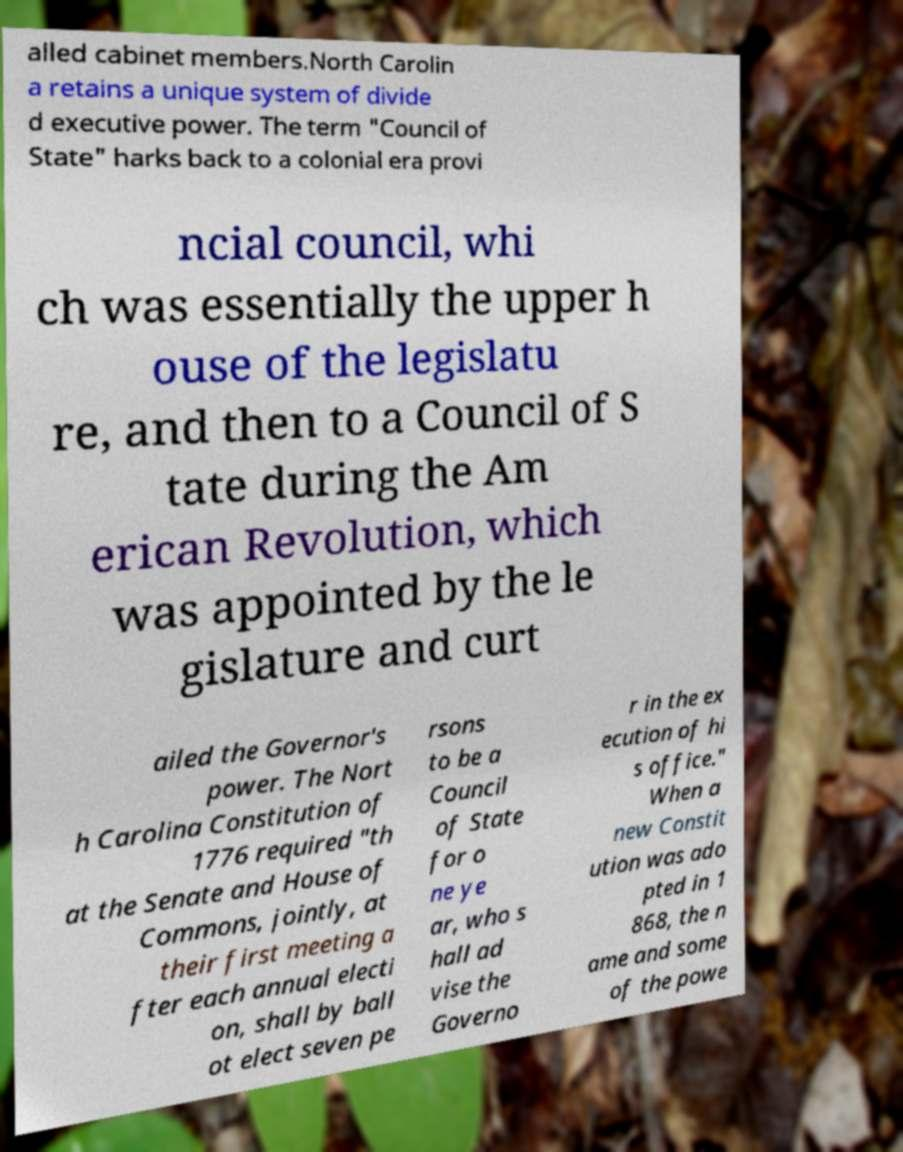I need the written content from this picture converted into text. Can you do that? alled cabinet members.North Carolin a retains a unique system of divide d executive power. The term "Council of State" harks back to a colonial era provi ncial council, whi ch was essentially the upper h ouse of the legislatu re, and then to a Council of S tate during the Am erican Revolution, which was appointed by the le gislature and curt ailed the Governor's power. The Nort h Carolina Constitution of 1776 required "th at the Senate and House of Commons, jointly, at their first meeting a fter each annual electi on, shall by ball ot elect seven pe rsons to be a Council of State for o ne ye ar, who s hall ad vise the Governo r in the ex ecution of hi s office." When a new Constit ution was ado pted in 1 868, the n ame and some of the powe 